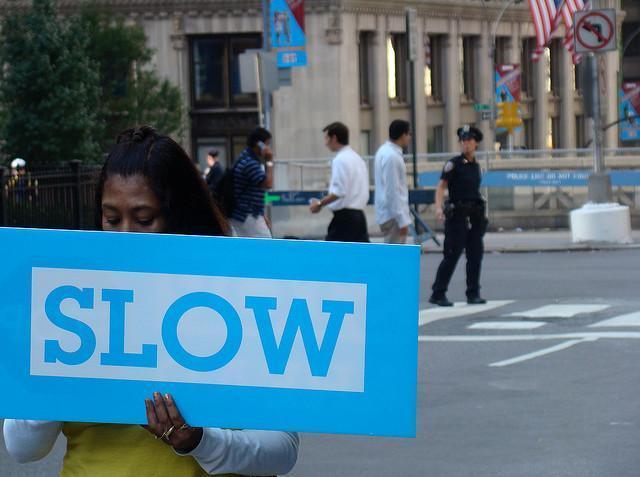How many police officers are there?
Give a very brief answer. 1. How many vowels in the sign she's holding?
Give a very brief answer. 1. How many people are in the picture?
Give a very brief answer. 5. How many orange fruit are there?
Give a very brief answer. 0. 